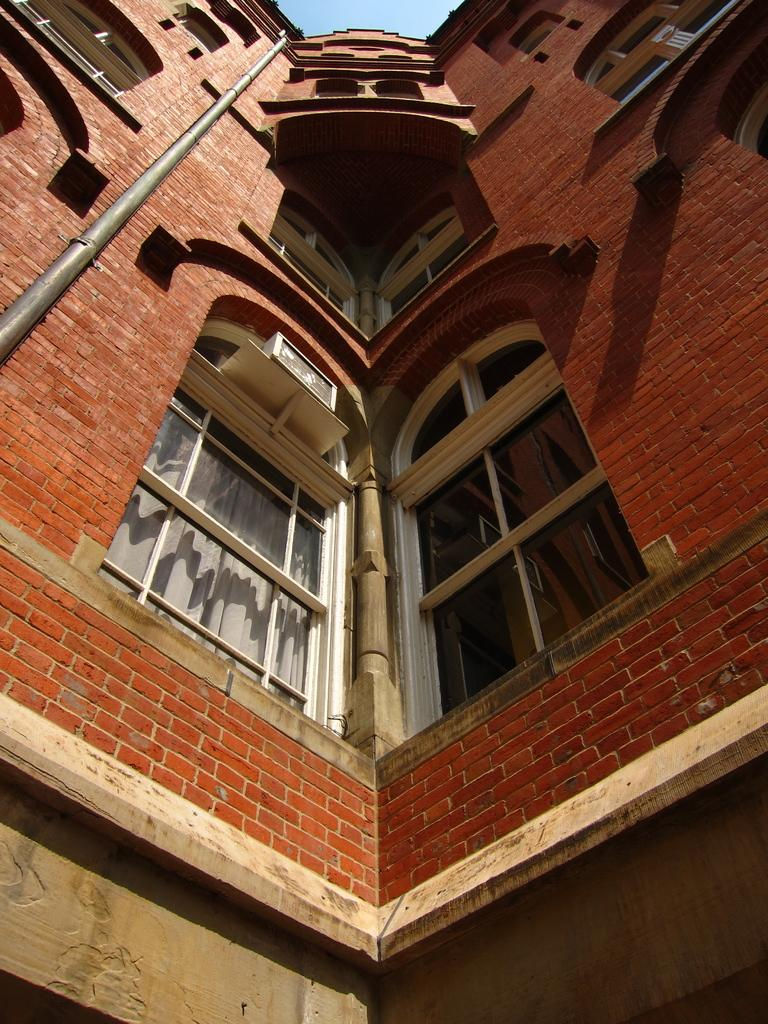What is the main subject in the center of the image? There is a building in the center of the image. What feature can be seen on the building? The building has windows. What object is located on the left side of the image? There is a pole on the left side of the image. What type of apparel is hanging on the pole in the image? There is no apparel present on the pole in the image. How does the sink in the image contribute to the overall scene? There is no sink present in the image. 